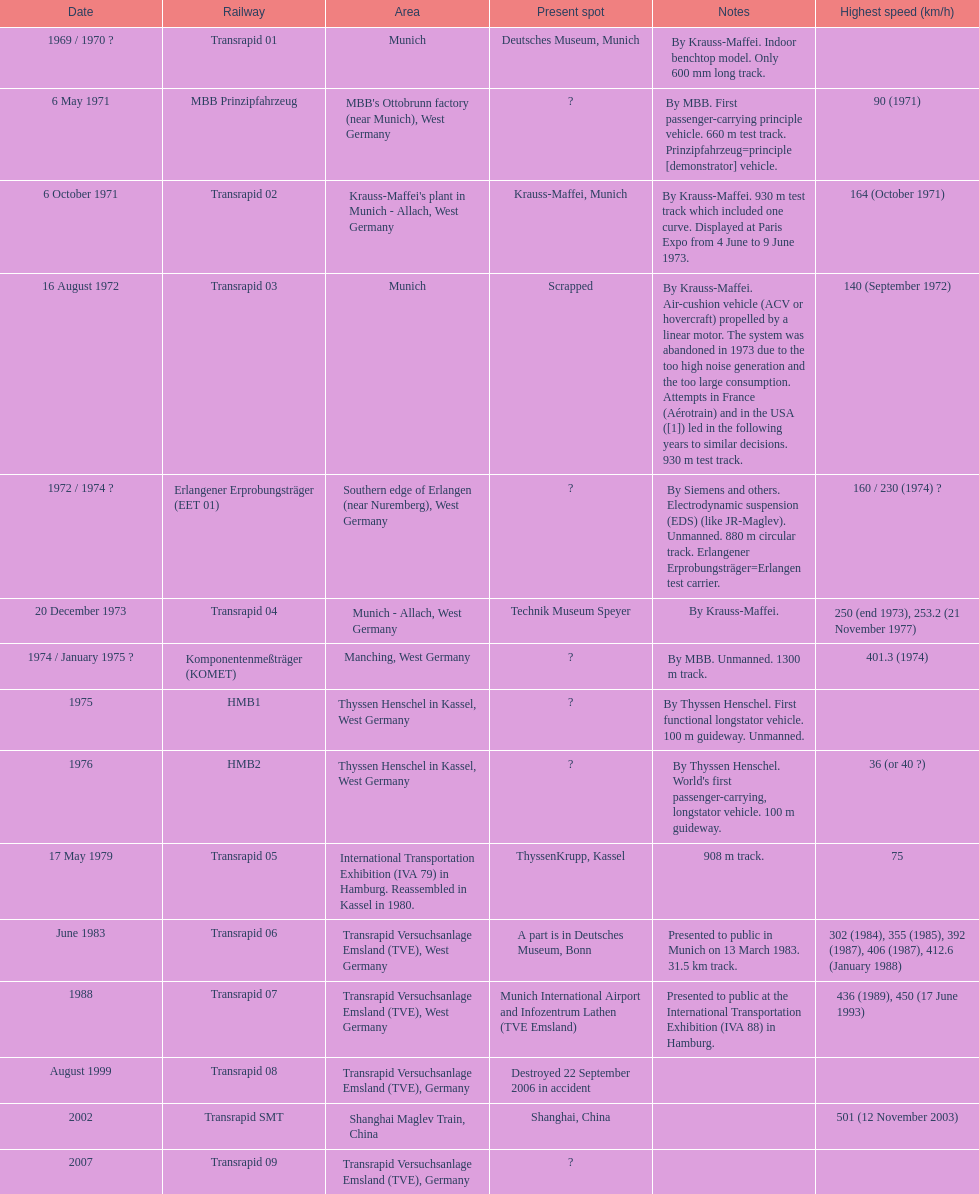What is the only train to reach a top speed of 500 or more? Transrapid SMT. 